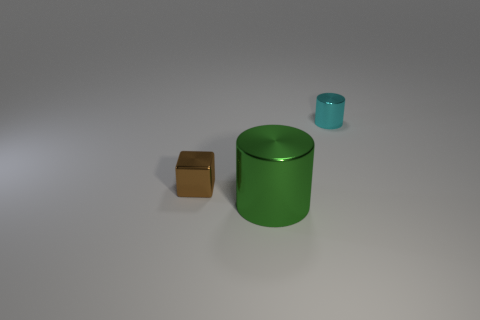How many blue objects are metal objects or shiny cylinders?
Give a very brief answer. 0. Is there a brown block that has the same size as the green metal cylinder?
Make the answer very short. No. Is the number of brown objects that are right of the small brown shiny block the same as the number of tiny cyan blocks?
Your answer should be very brief. Yes. Does the object that is in front of the cube have the same material as the cylinder behind the green metal cylinder?
Offer a terse response. Yes. How many things are small brown rubber cubes or things that are in front of the block?
Make the answer very short. 1. Are there any big yellow metal things that have the same shape as the cyan thing?
Ensure brevity in your answer.  No. There is a cylinder in front of the shiny object to the left of the thing in front of the small brown shiny cube; how big is it?
Offer a terse response. Large. Are there an equal number of big objects that are to the left of the large cylinder and metallic cylinders behind the brown metal cube?
Make the answer very short. No. There is a green cylinder that is the same material as the small brown block; what size is it?
Provide a succinct answer. Large. What is the color of the large cylinder?
Your answer should be very brief. Green. 